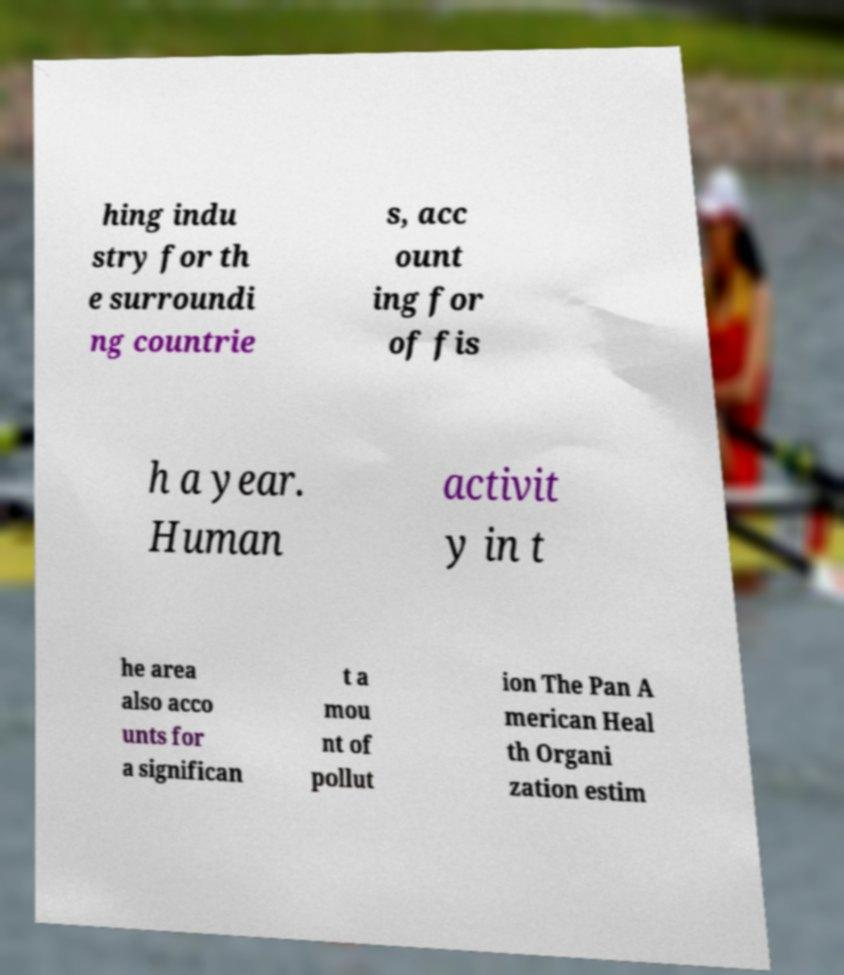Could you extract and type out the text from this image? hing indu stry for th e surroundi ng countrie s, acc ount ing for of fis h a year. Human activit y in t he area also acco unts for a significan t a mou nt of pollut ion The Pan A merican Heal th Organi zation estim 